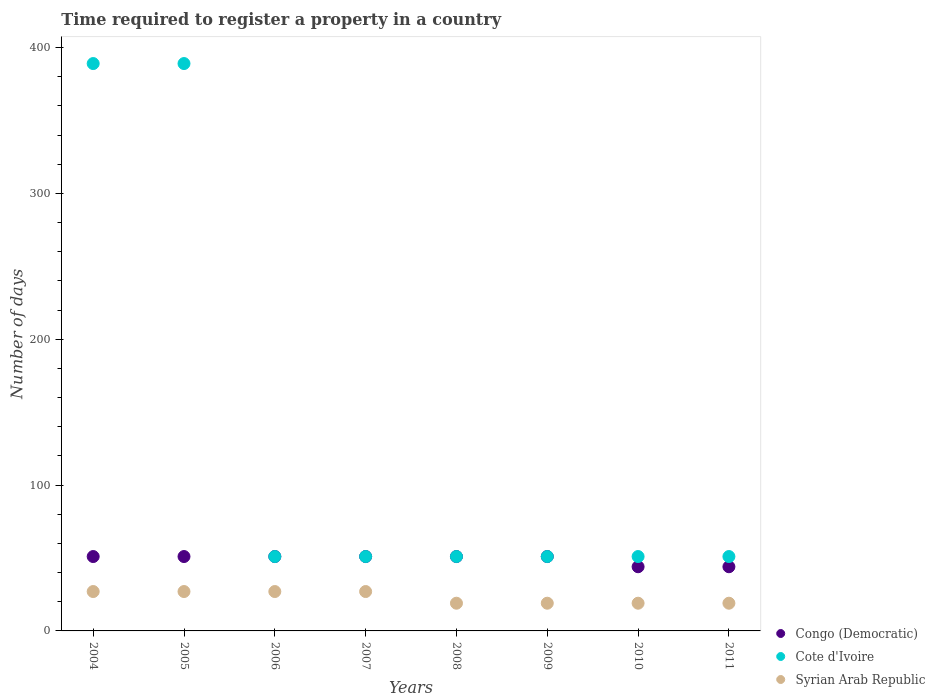What is the number of days required to register a property in Syrian Arab Republic in 2008?
Give a very brief answer. 19. Across all years, what is the maximum number of days required to register a property in Cote d'Ivoire?
Your answer should be compact. 389. Across all years, what is the minimum number of days required to register a property in Syrian Arab Republic?
Your response must be concise. 19. What is the total number of days required to register a property in Syrian Arab Republic in the graph?
Offer a very short reply. 184. What is the difference between the number of days required to register a property in Cote d'Ivoire in 2005 and that in 2008?
Make the answer very short. 338. What is the difference between the number of days required to register a property in Syrian Arab Republic in 2011 and the number of days required to register a property in Congo (Democratic) in 2004?
Your answer should be compact. -32. What is the average number of days required to register a property in Syrian Arab Republic per year?
Your answer should be compact. 23. In the year 2008, what is the difference between the number of days required to register a property in Cote d'Ivoire and number of days required to register a property in Syrian Arab Republic?
Provide a succinct answer. 32. In how many years, is the number of days required to register a property in Syrian Arab Republic greater than 280 days?
Ensure brevity in your answer.  0. What is the ratio of the number of days required to register a property in Congo (Democratic) in 2004 to that in 2006?
Ensure brevity in your answer.  1. Is the number of days required to register a property in Congo (Democratic) in 2004 less than that in 2007?
Make the answer very short. No. What is the difference between the highest and the second highest number of days required to register a property in Congo (Democratic)?
Ensure brevity in your answer.  0. What is the difference between the highest and the lowest number of days required to register a property in Congo (Democratic)?
Give a very brief answer. 7. Is it the case that in every year, the sum of the number of days required to register a property in Syrian Arab Republic and number of days required to register a property in Cote d'Ivoire  is greater than the number of days required to register a property in Congo (Democratic)?
Give a very brief answer. Yes. Does the number of days required to register a property in Syrian Arab Republic monotonically increase over the years?
Provide a succinct answer. No. Is the number of days required to register a property in Cote d'Ivoire strictly greater than the number of days required to register a property in Congo (Democratic) over the years?
Offer a very short reply. No. Is the number of days required to register a property in Cote d'Ivoire strictly less than the number of days required to register a property in Congo (Democratic) over the years?
Your response must be concise. No. How many years are there in the graph?
Your answer should be very brief. 8. Does the graph contain grids?
Offer a very short reply. No. How are the legend labels stacked?
Your answer should be very brief. Vertical. What is the title of the graph?
Provide a short and direct response. Time required to register a property in a country. Does "Syrian Arab Republic" appear as one of the legend labels in the graph?
Your response must be concise. Yes. What is the label or title of the X-axis?
Make the answer very short. Years. What is the label or title of the Y-axis?
Make the answer very short. Number of days. What is the Number of days of Congo (Democratic) in 2004?
Your response must be concise. 51. What is the Number of days of Cote d'Ivoire in 2004?
Provide a short and direct response. 389. What is the Number of days in Syrian Arab Republic in 2004?
Give a very brief answer. 27. What is the Number of days in Congo (Democratic) in 2005?
Give a very brief answer. 51. What is the Number of days of Cote d'Ivoire in 2005?
Give a very brief answer. 389. What is the Number of days in Syrian Arab Republic in 2005?
Offer a very short reply. 27. What is the Number of days in Cote d'Ivoire in 2006?
Offer a terse response. 51. What is the Number of days of Syrian Arab Republic in 2006?
Offer a terse response. 27. What is the Number of days in Congo (Democratic) in 2007?
Give a very brief answer. 51. What is the Number of days of Cote d'Ivoire in 2007?
Your answer should be compact. 51. What is the Number of days of Syrian Arab Republic in 2009?
Make the answer very short. 19. What is the Number of days in Congo (Democratic) in 2010?
Provide a short and direct response. 44. What is the Number of days of Cote d'Ivoire in 2011?
Your answer should be compact. 51. What is the Number of days in Syrian Arab Republic in 2011?
Offer a terse response. 19. Across all years, what is the maximum Number of days of Congo (Democratic)?
Offer a terse response. 51. Across all years, what is the maximum Number of days in Cote d'Ivoire?
Offer a terse response. 389. Across all years, what is the maximum Number of days of Syrian Arab Republic?
Provide a short and direct response. 27. Across all years, what is the minimum Number of days in Congo (Democratic)?
Give a very brief answer. 44. What is the total Number of days of Congo (Democratic) in the graph?
Offer a terse response. 394. What is the total Number of days in Cote d'Ivoire in the graph?
Your answer should be very brief. 1084. What is the total Number of days in Syrian Arab Republic in the graph?
Offer a very short reply. 184. What is the difference between the Number of days of Cote d'Ivoire in 2004 and that in 2005?
Make the answer very short. 0. What is the difference between the Number of days in Congo (Democratic) in 2004 and that in 2006?
Your answer should be compact. 0. What is the difference between the Number of days of Cote d'Ivoire in 2004 and that in 2006?
Make the answer very short. 338. What is the difference between the Number of days in Syrian Arab Republic in 2004 and that in 2006?
Your answer should be very brief. 0. What is the difference between the Number of days in Congo (Democratic) in 2004 and that in 2007?
Offer a terse response. 0. What is the difference between the Number of days in Cote d'Ivoire in 2004 and that in 2007?
Provide a short and direct response. 338. What is the difference between the Number of days of Congo (Democratic) in 2004 and that in 2008?
Give a very brief answer. 0. What is the difference between the Number of days in Cote d'Ivoire in 2004 and that in 2008?
Your answer should be very brief. 338. What is the difference between the Number of days of Congo (Democratic) in 2004 and that in 2009?
Your answer should be very brief. 0. What is the difference between the Number of days in Cote d'Ivoire in 2004 and that in 2009?
Your answer should be compact. 338. What is the difference between the Number of days of Cote d'Ivoire in 2004 and that in 2010?
Offer a very short reply. 338. What is the difference between the Number of days of Congo (Democratic) in 2004 and that in 2011?
Make the answer very short. 7. What is the difference between the Number of days of Cote d'Ivoire in 2004 and that in 2011?
Provide a short and direct response. 338. What is the difference between the Number of days in Syrian Arab Republic in 2004 and that in 2011?
Your answer should be very brief. 8. What is the difference between the Number of days in Cote d'Ivoire in 2005 and that in 2006?
Offer a terse response. 338. What is the difference between the Number of days of Syrian Arab Republic in 2005 and that in 2006?
Offer a very short reply. 0. What is the difference between the Number of days in Cote d'Ivoire in 2005 and that in 2007?
Offer a very short reply. 338. What is the difference between the Number of days in Congo (Democratic) in 2005 and that in 2008?
Provide a short and direct response. 0. What is the difference between the Number of days of Cote d'Ivoire in 2005 and that in 2008?
Provide a short and direct response. 338. What is the difference between the Number of days of Cote d'Ivoire in 2005 and that in 2009?
Ensure brevity in your answer.  338. What is the difference between the Number of days of Syrian Arab Republic in 2005 and that in 2009?
Offer a terse response. 8. What is the difference between the Number of days of Cote d'Ivoire in 2005 and that in 2010?
Ensure brevity in your answer.  338. What is the difference between the Number of days of Syrian Arab Republic in 2005 and that in 2010?
Give a very brief answer. 8. What is the difference between the Number of days in Cote d'Ivoire in 2005 and that in 2011?
Your response must be concise. 338. What is the difference between the Number of days of Syrian Arab Republic in 2005 and that in 2011?
Make the answer very short. 8. What is the difference between the Number of days in Congo (Democratic) in 2006 and that in 2007?
Provide a short and direct response. 0. What is the difference between the Number of days of Syrian Arab Republic in 2006 and that in 2007?
Your answer should be compact. 0. What is the difference between the Number of days of Congo (Democratic) in 2006 and that in 2008?
Your answer should be very brief. 0. What is the difference between the Number of days of Cote d'Ivoire in 2006 and that in 2008?
Give a very brief answer. 0. What is the difference between the Number of days of Congo (Democratic) in 2006 and that in 2009?
Ensure brevity in your answer.  0. What is the difference between the Number of days in Cote d'Ivoire in 2006 and that in 2009?
Keep it short and to the point. 0. What is the difference between the Number of days of Syrian Arab Republic in 2006 and that in 2009?
Offer a terse response. 8. What is the difference between the Number of days in Syrian Arab Republic in 2006 and that in 2010?
Provide a succinct answer. 8. What is the difference between the Number of days in Cote d'Ivoire in 2006 and that in 2011?
Ensure brevity in your answer.  0. What is the difference between the Number of days in Cote d'Ivoire in 2007 and that in 2008?
Make the answer very short. 0. What is the difference between the Number of days of Syrian Arab Republic in 2007 and that in 2008?
Your response must be concise. 8. What is the difference between the Number of days in Congo (Democratic) in 2007 and that in 2009?
Your answer should be compact. 0. What is the difference between the Number of days of Cote d'Ivoire in 2007 and that in 2011?
Offer a very short reply. 0. What is the difference between the Number of days in Syrian Arab Republic in 2007 and that in 2011?
Provide a succinct answer. 8. What is the difference between the Number of days in Cote d'Ivoire in 2008 and that in 2009?
Give a very brief answer. 0. What is the difference between the Number of days of Syrian Arab Republic in 2008 and that in 2009?
Your response must be concise. 0. What is the difference between the Number of days in Congo (Democratic) in 2008 and that in 2010?
Offer a very short reply. 7. What is the difference between the Number of days of Cote d'Ivoire in 2008 and that in 2010?
Keep it short and to the point. 0. What is the difference between the Number of days of Syrian Arab Republic in 2008 and that in 2010?
Make the answer very short. 0. What is the difference between the Number of days in Cote d'Ivoire in 2008 and that in 2011?
Offer a very short reply. 0. What is the difference between the Number of days in Syrian Arab Republic in 2008 and that in 2011?
Make the answer very short. 0. What is the difference between the Number of days in Cote d'Ivoire in 2009 and that in 2010?
Give a very brief answer. 0. What is the difference between the Number of days in Syrian Arab Republic in 2009 and that in 2010?
Your response must be concise. 0. What is the difference between the Number of days of Congo (Democratic) in 2009 and that in 2011?
Give a very brief answer. 7. What is the difference between the Number of days of Syrian Arab Republic in 2010 and that in 2011?
Give a very brief answer. 0. What is the difference between the Number of days in Congo (Democratic) in 2004 and the Number of days in Cote d'Ivoire in 2005?
Your answer should be very brief. -338. What is the difference between the Number of days in Cote d'Ivoire in 2004 and the Number of days in Syrian Arab Republic in 2005?
Offer a very short reply. 362. What is the difference between the Number of days in Congo (Democratic) in 2004 and the Number of days in Cote d'Ivoire in 2006?
Provide a short and direct response. 0. What is the difference between the Number of days in Congo (Democratic) in 2004 and the Number of days in Syrian Arab Republic in 2006?
Make the answer very short. 24. What is the difference between the Number of days of Cote d'Ivoire in 2004 and the Number of days of Syrian Arab Republic in 2006?
Offer a very short reply. 362. What is the difference between the Number of days of Congo (Democratic) in 2004 and the Number of days of Syrian Arab Republic in 2007?
Keep it short and to the point. 24. What is the difference between the Number of days of Cote d'Ivoire in 2004 and the Number of days of Syrian Arab Republic in 2007?
Your answer should be very brief. 362. What is the difference between the Number of days in Congo (Democratic) in 2004 and the Number of days in Cote d'Ivoire in 2008?
Your answer should be very brief. 0. What is the difference between the Number of days of Congo (Democratic) in 2004 and the Number of days of Syrian Arab Republic in 2008?
Provide a short and direct response. 32. What is the difference between the Number of days in Cote d'Ivoire in 2004 and the Number of days in Syrian Arab Republic in 2008?
Keep it short and to the point. 370. What is the difference between the Number of days of Cote d'Ivoire in 2004 and the Number of days of Syrian Arab Republic in 2009?
Offer a terse response. 370. What is the difference between the Number of days of Congo (Democratic) in 2004 and the Number of days of Syrian Arab Republic in 2010?
Give a very brief answer. 32. What is the difference between the Number of days of Cote d'Ivoire in 2004 and the Number of days of Syrian Arab Republic in 2010?
Your response must be concise. 370. What is the difference between the Number of days of Cote d'Ivoire in 2004 and the Number of days of Syrian Arab Republic in 2011?
Your answer should be very brief. 370. What is the difference between the Number of days of Congo (Democratic) in 2005 and the Number of days of Cote d'Ivoire in 2006?
Your response must be concise. 0. What is the difference between the Number of days in Cote d'Ivoire in 2005 and the Number of days in Syrian Arab Republic in 2006?
Your answer should be very brief. 362. What is the difference between the Number of days of Congo (Democratic) in 2005 and the Number of days of Syrian Arab Republic in 2007?
Offer a very short reply. 24. What is the difference between the Number of days in Cote d'Ivoire in 2005 and the Number of days in Syrian Arab Republic in 2007?
Ensure brevity in your answer.  362. What is the difference between the Number of days of Congo (Democratic) in 2005 and the Number of days of Cote d'Ivoire in 2008?
Offer a very short reply. 0. What is the difference between the Number of days in Congo (Democratic) in 2005 and the Number of days in Syrian Arab Republic in 2008?
Your response must be concise. 32. What is the difference between the Number of days of Cote d'Ivoire in 2005 and the Number of days of Syrian Arab Republic in 2008?
Keep it short and to the point. 370. What is the difference between the Number of days of Cote d'Ivoire in 2005 and the Number of days of Syrian Arab Republic in 2009?
Make the answer very short. 370. What is the difference between the Number of days of Congo (Democratic) in 2005 and the Number of days of Syrian Arab Republic in 2010?
Your answer should be very brief. 32. What is the difference between the Number of days of Cote d'Ivoire in 2005 and the Number of days of Syrian Arab Republic in 2010?
Provide a succinct answer. 370. What is the difference between the Number of days in Congo (Democratic) in 2005 and the Number of days in Syrian Arab Republic in 2011?
Your response must be concise. 32. What is the difference between the Number of days in Cote d'Ivoire in 2005 and the Number of days in Syrian Arab Republic in 2011?
Your response must be concise. 370. What is the difference between the Number of days in Congo (Democratic) in 2006 and the Number of days in Cote d'Ivoire in 2007?
Your answer should be compact. 0. What is the difference between the Number of days in Congo (Democratic) in 2006 and the Number of days in Cote d'Ivoire in 2008?
Offer a very short reply. 0. What is the difference between the Number of days in Congo (Democratic) in 2006 and the Number of days in Syrian Arab Republic in 2008?
Keep it short and to the point. 32. What is the difference between the Number of days of Cote d'Ivoire in 2006 and the Number of days of Syrian Arab Republic in 2008?
Make the answer very short. 32. What is the difference between the Number of days of Congo (Democratic) in 2006 and the Number of days of Cote d'Ivoire in 2009?
Offer a terse response. 0. What is the difference between the Number of days of Congo (Democratic) in 2006 and the Number of days of Syrian Arab Republic in 2009?
Ensure brevity in your answer.  32. What is the difference between the Number of days of Cote d'Ivoire in 2006 and the Number of days of Syrian Arab Republic in 2009?
Ensure brevity in your answer.  32. What is the difference between the Number of days of Congo (Democratic) in 2006 and the Number of days of Cote d'Ivoire in 2010?
Make the answer very short. 0. What is the difference between the Number of days of Cote d'Ivoire in 2006 and the Number of days of Syrian Arab Republic in 2010?
Your response must be concise. 32. What is the difference between the Number of days in Congo (Democratic) in 2006 and the Number of days in Cote d'Ivoire in 2011?
Offer a very short reply. 0. What is the difference between the Number of days in Cote d'Ivoire in 2006 and the Number of days in Syrian Arab Republic in 2011?
Keep it short and to the point. 32. What is the difference between the Number of days of Congo (Democratic) in 2007 and the Number of days of Cote d'Ivoire in 2008?
Your answer should be very brief. 0. What is the difference between the Number of days in Congo (Democratic) in 2007 and the Number of days in Syrian Arab Republic in 2008?
Your answer should be very brief. 32. What is the difference between the Number of days in Congo (Democratic) in 2007 and the Number of days in Syrian Arab Republic in 2009?
Offer a terse response. 32. What is the difference between the Number of days in Cote d'Ivoire in 2007 and the Number of days in Syrian Arab Republic in 2009?
Offer a very short reply. 32. What is the difference between the Number of days in Congo (Democratic) in 2007 and the Number of days in Cote d'Ivoire in 2010?
Provide a succinct answer. 0. What is the difference between the Number of days of Congo (Democratic) in 2007 and the Number of days of Cote d'Ivoire in 2011?
Your response must be concise. 0. What is the difference between the Number of days of Congo (Democratic) in 2008 and the Number of days of Cote d'Ivoire in 2009?
Make the answer very short. 0. What is the difference between the Number of days in Congo (Democratic) in 2008 and the Number of days in Syrian Arab Republic in 2009?
Provide a short and direct response. 32. What is the difference between the Number of days in Cote d'Ivoire in 2008 and the Number of days in Syrian Arab Republic in 2009?
Provide a succinct answer. 32. What is the difference between the Number of days of Cote d'Ivoire in 2008 and the Number of days of Syrian Arab Republic in 2010?
Offer a terse response. 32. What is the difference between the Number of days of Congo (Democratic) in 2008 and the Number of days of Cote d'Ivoire in 2011?
Give a very brief answer. 0. What is the difference between the Number of days in Congo (Democratic) in 2008 and the Number of days in Syrian Arab Republic in 2011?
Make the answer very short. 32. What is the difference between the Number of days of Congo (Democratic) in 2009 and the Number of days of Cote d'Ivoire in 2010?
Give a very brief answer. 0. What is the difference between the Number of days in Congo (Democratic) in 2009 and the Number of days in Syrian Arab Republic in 2010?
Give a very brief answer. 32. What is the difference between the Number of days of Cote d'Ivoire in 2009 and the Number of days of Syrian Arab Republic in 2010?
Your answer should be compact. 32. What is the difference between the Number of days in Congo (Democratic) in 2009 and the Number of days in Cote d'Ivoire in 2011?
Offer a terse response. 0. What is the difference between the Number of days of Congo (Democratic) in 2009 and the Number of days of Syrian Arab Republic in 2011?
Give a very brief answer. 32. What is the difference between the Number of days in Cote d'Ivoire in 2009 and the Number of days in Syrian Arab Republic in 2011?
Your response must be concise. 32. What is the difference between the Number of days of Congo (Democratic) in 2010 and the Number of days of Cote d'Ivoire in 2011?
Ensure brevity in your answer.  -7. What is the difference between the Number of days in Congo (Democratic) in 2010 and the Number of days in Syrian Arab Republic in 2011?
Provide a succinct answer. 25. What is the difference between the Number of days in Cote d'Ivoire in 2010 and the Number of days in Syrian Arab Republic in 2011?
Offer a very short reply. 32. What is the average Number of days of Congo (Democratic) per year?
Your answer should be compact. 49.25. What is the average Number of days of Cote d'Ivoire per year?
Offer a very short reply. 135.5. In the year 2004, what is the difference between the Number of days in Congo (Democratic) and Number of days in Cote d'Ivoire?
Provide a succinct answer. -338. In the year 2004, what is the difference between the Number of days in Congo (Democratic) and Number of days in Syrian Arab Republic?
Offer a very short reply. 24. In the year 2004, what is the difference between the Number of days of Cote d'Ivoire and Number of days of Syrian Arab Republic?
Offer a terse response. 362. In the year 2005, what is the difference between the Number of days of Congo (Democratic) and Number of days of Cote d'Ivoire?
Ensure brevity in your answer.  -338. In the year 2005, what is the difference between the Number of days of Congo (Democratic) and Number of days of Syrian Arab Republic?
Make the answer very short. 24. In the year 2005, what is the difference between the Number of days of Cote d'Ivoire and Number of days of Syrian Arab Republic?
Offer a very short reply. 362. In the year 2006, what is the difference between the Number of days in Congo (Democratic) and Number of days in Cote d'Ivoire?
Keep it short and to the point. 0. In the year 2006, what is the difference between the Number of days of Cote d'Ivoire and Number of days of Syrian Arab Republic?
Make the answer very short. 24. In the year 2007, what is the difference between the Number of days in Congo (Democratic) and Number of days in Syrian Arab Republic?
Make the answer very short. 24. In the year 2007, what is the difference between the Number of days in Cote d'Ivoire and Number of days in Syrian Arab Republic?
Keep it short and to the point. 24. In the year 2008, what is the difference between the Number of days of Congo (Democratic) and Number of days of Syrian Arab Republic?
Provide a short and direct response. 32. In the year 2008, what is the difference between the Number of days in Cote d'Ivoire and Number of days in Syrian Arab Republic?
Make the answer very short. 32. In the year 2009, what is the difference between the Number of days in Congo (Democratic) and Number of days in Cote d'Ivoire?
Ensure brevity in your answer.  0. In the year 2009, what is the difference between the Number of days of Congo (Democratic) and Number of days of Syrian Arab Republic?
Ensure brevity in your answer.  32. In the year 2009, what is the difference between the Number of days of Cote d'Ivoire and Number of days of Syrian Arab Republic?
Your response must be concise. 32. In the year 2010, what is the difference between the Number of days in Cote d'Ivoire and Number of days in Syrian Arab Republic?
Offer a very short reply. 32. In the year 2011, what is the difference between the Number of days in Congo (Democratic) and Number of days in Cote d'Ivoire?
Ensure brevity in your answer.  -7. In the year 2011, what is the difference between the Number of days in Cote d'Ivoire and Number of days in Syrian Arab Republic?
Your answer should be compact. 32. What is the ratio of the Number of days in Cote d'Ivoire in 2004 to that in 2005?
Your answer should be very brief. 1. What is the ratio of the Number of days in Congo (Democratic) in 2004 to that in 2006?
Offer a very short reply. 1. What is the ratio of the Number of days of Cote d'Ivoire in 2004 to that in 2006?
Make the answer very short. 7.63. What is the ratio of the Number of days in Cote d'Ivoire in 2004 to that in 2007?
Your answer should be compact. 7.63. What is the ratio of the Number of days of Cote d'Ivoire in 2004 to that in 2008?
Offer a terse response. 7.63. What is the ratio of the Number of days of Syrian Arab Republic in 2004 to that in 2008?
Your response must be concise. 1.42. What is the ratio of the Number of days in Congo (Democratic) in 2004 to that in 2009?
Keep it short and to the point. 1. What is the ratio of the Number of days of Cote d'Ivoire in 2004 to that in 2009?
Your response must be concise. 7.63. What is the ratio of the Number of days in Syrian Arab Republic in 2004 to that in 2009?
Keep it short and to the point. 1.42. What is the ratio of the Number of days of Congo (Democratic) in 2004 to that in 2010?
Ensure brevity in your answer.  1.16. What is the ratio of the Number of days of Cote d'Ivoire in 2004 to that in 2010?
Your response must be concise. 7.63. What is the ratio of the Number of days of Syrian Arab Republic in 2004 to that in 2010?
Offer a terse response. 1.42. What is the ratio of the Number of days in Congo (Democratic) in 2004 to that in 2011?
Offer a terse response. 1.16. What is the ratio of the Number of days of Cote d'Ivoire in 2004 to that in 2011?
Ensure brevity in your answer.  7.63. What is the ratio of the Number of days of Syrian Arab Republic in 2004 to that in 2011?
Offer a terse response. 1.42. What is the ratio of the Number of days in Cote d'Ivoire in 2005 to that in 2006?
Give a very brief answer. 7.63. What is the ratio of the Number of days in Syrian Arab Republic in 2005 to that in 2006?
Give a very brief answer. 1. What is the ratio of the Number of days in Congo (Democratic) in 2005 to that in 2007?
Your response must be concise. 1. What is the ratio of the Number of days in Cote d'Ivoire in 2005 to that in 2007?
Keep it short and to the point. 7.63. What is the ratio of the Number of days of Congo (Democratic) in 2005 to that in 2008?
Give a very brief answer. 1. What is the ratio of the Number of days of Cote d'Ivoire in 2005 to that in 2008?
Provide a short and direct response. 7.63. What is the ratio of the Number of days in Syrian Arab Republic in 2005 to that in 2008?
Your answer should be very brief. 1.42. What is the ratio of the Number of days of Congo (Democratic) in 2005 to that in 2009?
Your answer should be very brief. 1. What is the ratio of the Number of days in Cote d'Ivoire in 2005 to that in 2009?
Offer a terse response. 7.63. What is the ratio of the Number of days of Syrian Arab Republic in 2005 to that in 2009?
Make the answer very short. 1.42. What is the ratio of the Number of days in Congo (Democratic) in 2005 to that in 2010?
Your response must be concise. 1.16. What is the ratio of the Number of days of Cote d'Ivoire in 2005 to that in 2010?
Your answer should be compact. 7.63. What is the ratio of the Number of days of Syrian Arab Republic in 2005 to that in 2010?
Provide a succinct answer. 1.42. What is the ratio of the Number of days of Congo (Democratic) in 2005 to that in 2011?
Offer a terse response. 1.16. What is the ratio of the Number of days of Cote d'Ivoire in 2005 to that in 2011?
Your answer should be compact. 7.63. What is the ratio of the Number of days of Syrian Arab Republic in 2005 to that in 2011?
Keep it short and to the point. 1.42. What is the ratio of the Number of days in Congo (Democratic) in 2006 to that in 2007?
Give a very brief answer. 1. What is the ratio of the Number of days of Cote d'Ivoire in 2006 to that in 2007?
Your answer should be very brief. 1. What is the ratio of the Number of days of Syrian Arab Republic in 2006 to that in 2007?
Provide a short and direct response. 1. What is the ratio of the Number of days in Congo (Democratic) in 2006 to that in 2008?
Give a very brief answer. 1. What is the ratio of the Number of days in Cote d'Ivoire in 2006 to that in 2008?
Ensure brevity in your answer.  1. What is the ratio of the Number of days in Syrian Arab Republic in 2006 to that in 2008?
Your response must be concise. 1.42. What is the ratio of the Number of days of Congo (Democratic) in 2006 to that in 2009?
Provide a short and direct response. 1. What is the ratio of the Number of days of Cote d'Ivoire in 2006 to that in 2009?
Provide a succinct answer. 1. What is the ratio of the Number of days of Syrian Arab Republic in 2006 to that in 2009?
Offer a very short reply. 1.42. What is the ratio of the Number of days of Congo (Democratic) in 2006 to that in 2010?
Offer a terse response. 1.16. What is the ratio of the Number of days in Syrian Arab Republic in 2006 to that in 2010?
Keep it short and to the point. 1.42. What is the ratio of the Number of days in Congo (Democratic) in 2006 to that in 2011?
Give a very brief answer. 1.16. What is the ratio of the Number of days of Cote d'Ivoire in 2006 to that in 2011?
Give a very brief answer. 1. What is the ratio of the Number of days of Syrian Arab Republic in 2006 to that in 2011?
Keep it short and to the point. 1.42. What is the ratio of the Number of days in Congo (Democratic) in 2007 to that in 2008?
Your answer should be very brief. 1. What is the ratio of the Number of days in Cote d'Ivoire in 2007 to that in 2008?
Provide a succinct answer. 1. What is the ratio of the Number of days of Syrian Arab Republic in 2007 to that in 2008?
Make the answer very short. 1.42. What is the ratio of the Number of days in Syrian Arab Republic in 2007 to that in 2009?
Offer a terse response. 1.42. What is the ratio of the Number of days of Congo (Democratic) in 2007 to that in 2010?
Keep it short and to the point. 1.16. What is the ratio of the Number of days in Syrian Arab Republic in 2007 to that in 2010?
Make the answer very short. 1.42. What is the ratio of the Number of days of Congo (Democratic) in 2007 to that in 2011?
Offer a terse response. 1.16. What is the ratio of the Number of days in Syrian Arab Republic in 2007 to that in 2011?
Offer a very short reply. 1.42. What is the ratio of the Number of days in Congo (Democratic) in 2008 to that in 2010?
Offer a very short reply. 1.16. What is the ratio of the Number of days in Syrian Arab Republic in 2008 to that in 2010?
Keep it short and to the point. 1. What is the ratio of the Number of days of Congo (Democratic) in 2008 to that in 2011?
Keep it short and to the point. 1.16. What is the ratio of the Number of days of Cote d'Ivoire in 2008 to that in 2011?
Provide a succinct answer. 1. What is the ratio of the Number of days in Syrian Arab Republic in 2008 to that in 2011?
Keep it short and to the point. 1. What is the ratio of the Number of days in Congo (Democratic) in 2009 to that in 2010?
Ensure brevity in your answer.  1.16. What is the ratio of the Number of days in Cote d'Ivoire in 2009 to that in 2010?
Your answer should be compact. 1. What is the ratio of the Number of days of Congo (Democratic) in 2009 to that in 2011?
Your response must be concise. 1.16. What is the ratio of the Number of days of Syrian Arab Republic in 2010 to that in 2011?
Provide a succinct answer. 1. What is the difference between the highest and the second highest Number of days in Congo (Democratic)?
Offer a very short reply. 0. What is the difference between the highest and the second highest Number of days of Cote d'Ivoire?
Your response must be concise. 0. What is the difference between the highest and the second highest Number of days of Syrian Arab Republic?
Make the answer very short. 0. What is the difference between the highest and the lowest Number of days of Cote d'Ivoire?
Give a very brief answer. 338. What is the difference between the highest and the lowest Number of days of Syrian Arab Republic?
Keep it short and to the point. 8. 